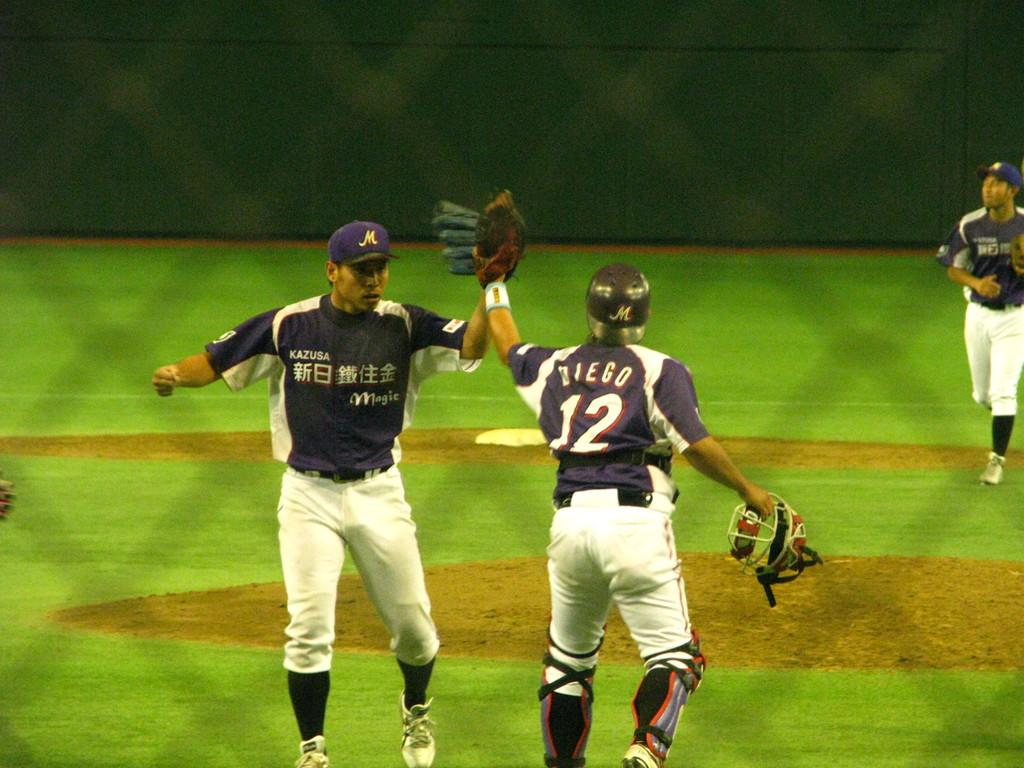<image>
Summarize the visual content of the image. Baseball player Diego is congratulating another baseball player. 